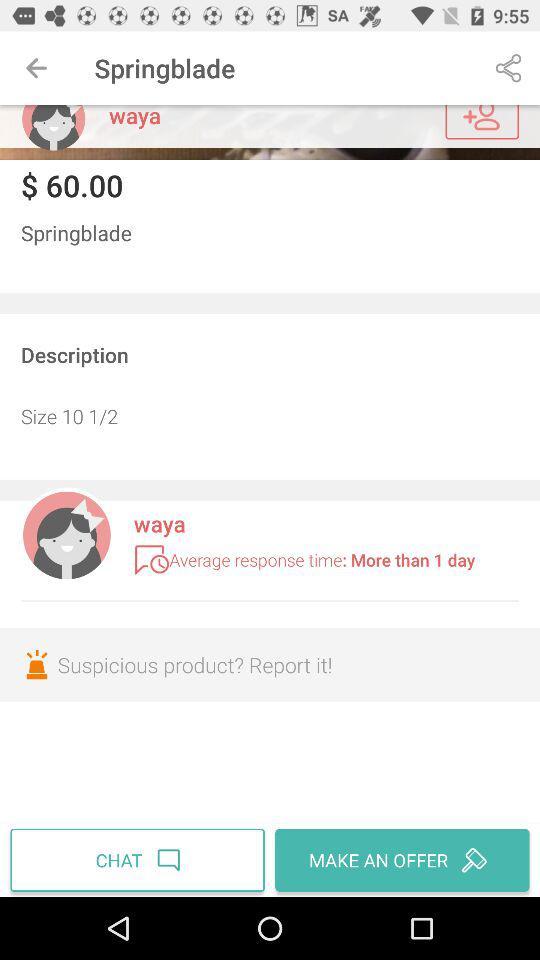What is the average response time? The average response time is more than 1 day. 